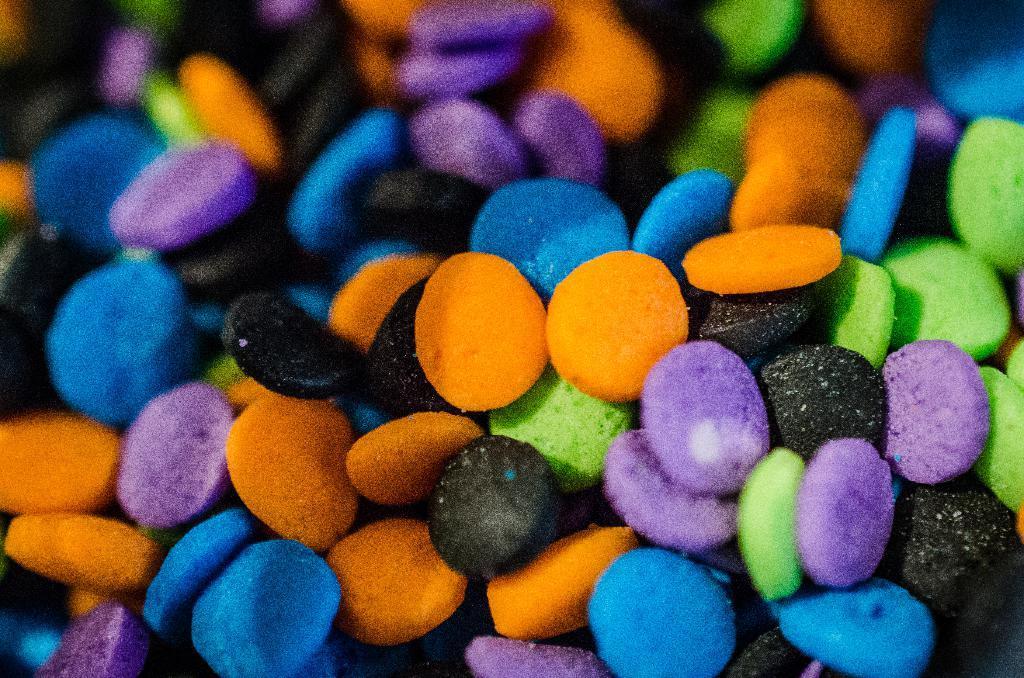How would you summarize this image in a sentence or two? In this picture we can see the candy. 